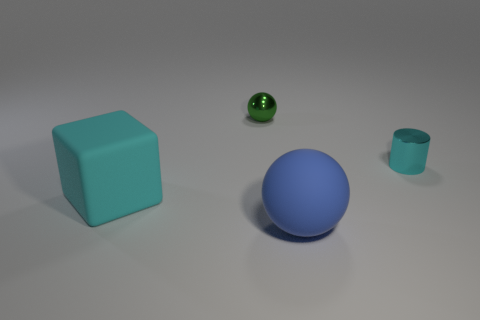Add 3 cyan shiny cylinders. How many objects exist? 7 Subtract 1 cyan cubes. How many objects are left? 3 Subtract all cylinders. How many objects are left? 3 Subtract all small purple spheres. Subtract all big cyan rubber cubes. How many objects are left? 3 Add 4 cyan cylinders. How many cyan cylinders are left? 5 Add 3 tiny cylinders. How many tiny cylinders exist? 4 